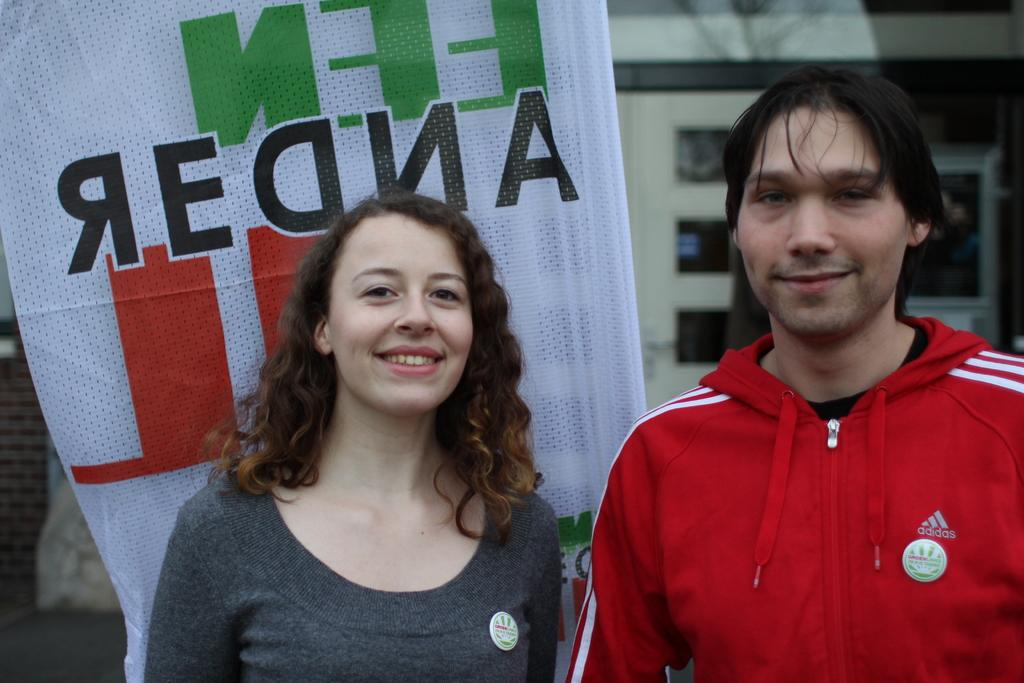How many people are in the image? There are two persons in the image. What is the text on the cloth in the image? The provided facts do not mention the text on the cloth, so we cannot answer that question. How would you describe the background of the image? The background of the image is blurred. What type of plough is being used by the persons in the image? There is no plough present in the image; it features two persons and a cloth with text. What language is the text on the cloth written in? The provided facts do not mention the language of the text on the cloth, so we cannot answer that question. 